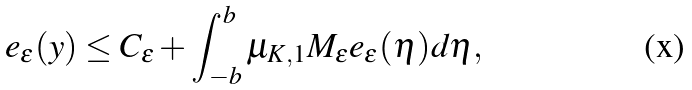<formula> <loc_0><loc_0><loc_500><loc_500>e _ { \varepsilon } ( y ) \leq C _ { \varepsilon } + \int _ { - b } ^ { b } \mu _ { K , 1 } M _ { \varepsilon } e _ { \varepsilon } ( \eta ) d \eta ,</formula> 